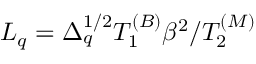Convert formula to latex. <formula><loc_0><loc_0><loc_500><loc_500>L _ { q } = \Delta _ { q } ^ { 1 / 2 } T _ { 1 } ^ { ( B ) } \beta ^ { 2 } / T _ { 2 } ^ { ( M ) }</formula> 